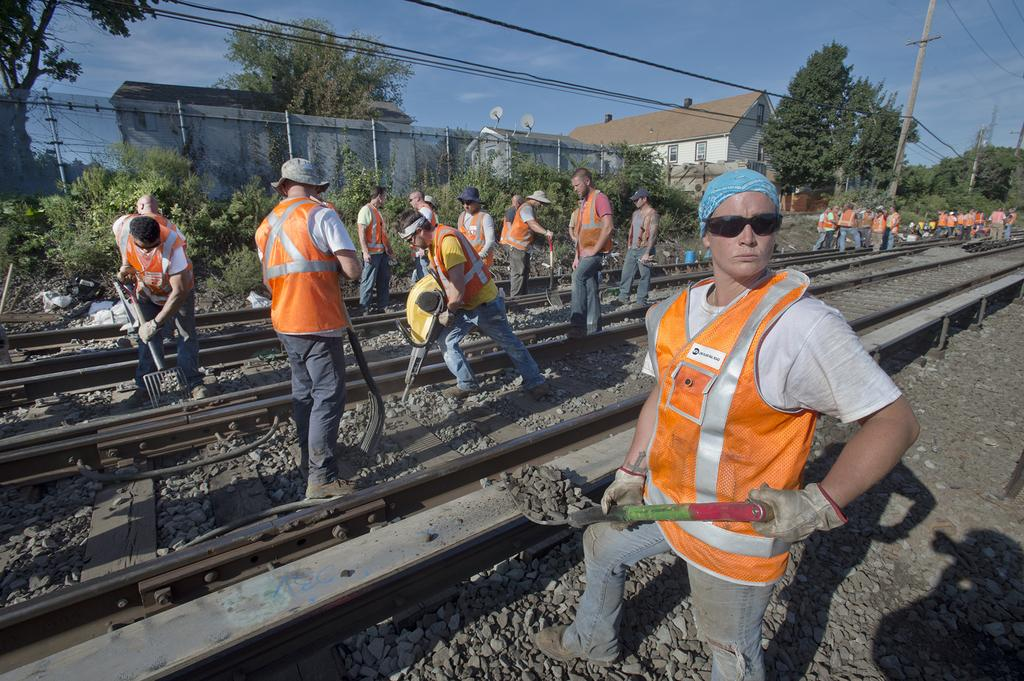What are the people in the image doing? The people in the image are working, using tools. What are they working on? They are working on tracks. What can be seen in the background of the image? There are trees, poles, houses, and the sky visible in the background of the image. What type of necklace is the person wearing in the image? There is no person wearing a necklace in the image. What fictional character can be seen working on the tracks in the image? There are no fictional characters present in the image; the people working are real individuals. 